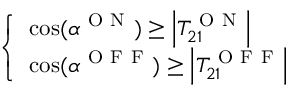<formula> <loc_0><loc_0><loc_500><loc_500>\left \{ \begin{array} { l } { \cos ( \alpha ^ { O N } ) \geq \left | T _ { 2 1 } ^ { O N } \right | } \\ { \cos ( \alpha ^ { O F F } ) \geq \left | T _ { 2 1 } ^ { O F F } \right | } \end{array}</formula> 